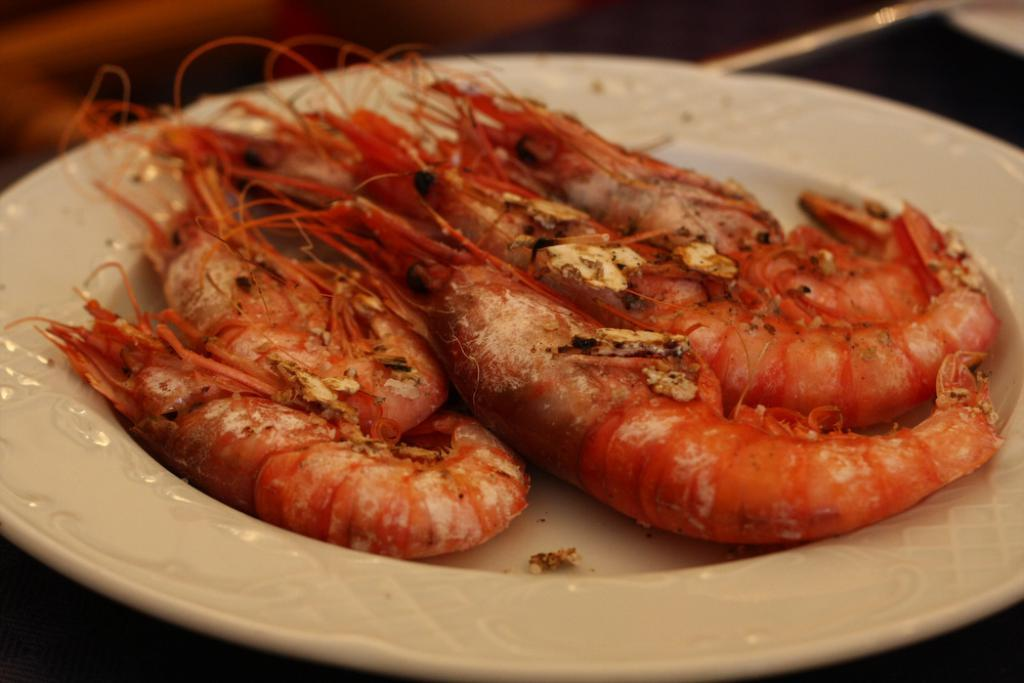What type of food is on the plate in the image? There is seafood on a plate in the image. Can you describe anything else in the image besides the seafood? Yes, there are objects at the top right corner of the image. What type of boot is being used as a representative for the feast in the image? There is no boot or feast present in the image; it only features seafood on a plate and objects at the top right corner. 